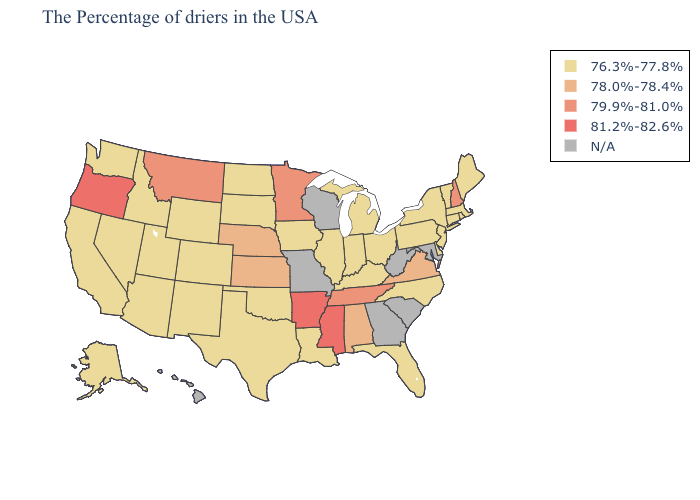What is the lowest value in states that border New Mexico?
Give a very brief answer. 76.3%-77.8%. Which states have the highest value in the USA?
Keep it brief. Mississippi, Arkansas, Oregon. What is the lowest value in states that border New Hampshire?
Be succinct. 76.3%-77.8%. What is the highest value in the USA?
Quick response, please. 81.2%-82.6%. Does Illinois have the highest value in the USA?
Give a very brief answer. No. What is the value of Indiana?
Short answer required. 76.3%-77.8%. Name the states that have a value in the range N/A?
Give a very brief answer. Maryland, South Carolina, West Virginia, Georgia, Wisconsin, Missouri, Hawaii. What is the lowest value in the South?
Answer briefly. 76.3%-77.8%. What is the value of Alabama?
Answer briefly. 78.0%-78.4%. What is the value of Utah?
Quick response, please. 76.3%-77.8%. Does Alabama have the lowest value in the USA?
Give a very brief answer. No. Among the states that border California , does Nevada have the lowest value?
Concise answer only. Yes. What is the lowest value in the South?
Write a very short answer. 76.3%-77.8%. Among the states that border North Dakota , does Minnesota have the lowest value?
Keep it brief. No. 